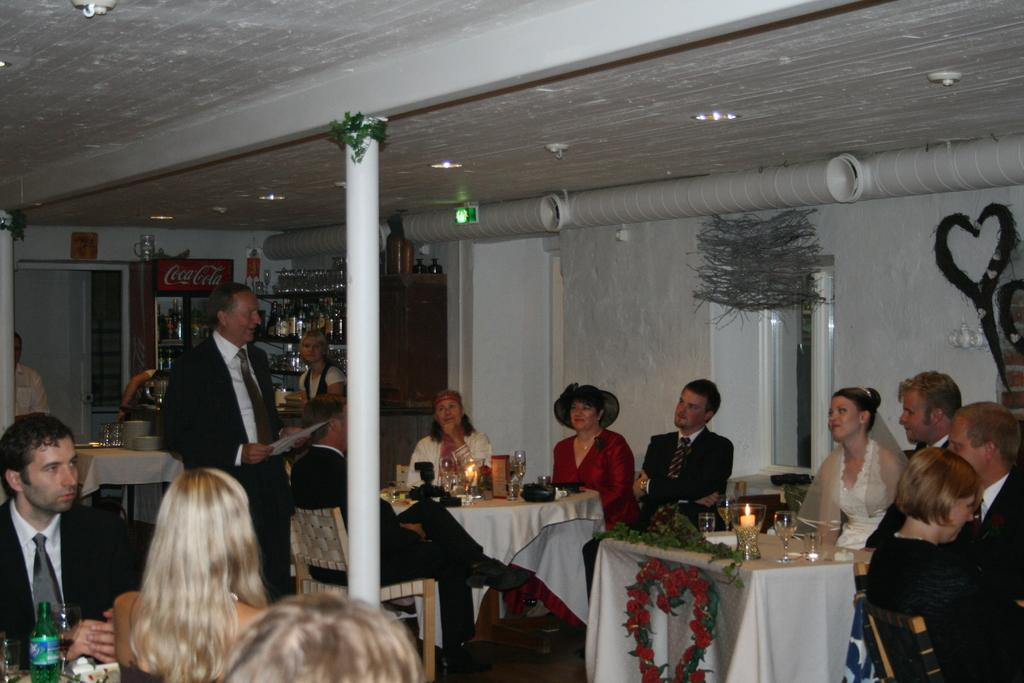What is the setting of the image? The setting of the image is a restaurant. What are the people in the image doing? The people are sitting in the restaurant. Can you describe the person standing in the middle of the group? The person standing in the middle of the group is wearing a black suit. What is the person in the black suit doing? The person in the black suit is speaking to the group. What can be seen in the background of the image? There is a Coca-Cola fridge in the background. What type of peace offering is the stranger holding in the image? There is no stranger present in the image, nor is there any peace offering visible. 